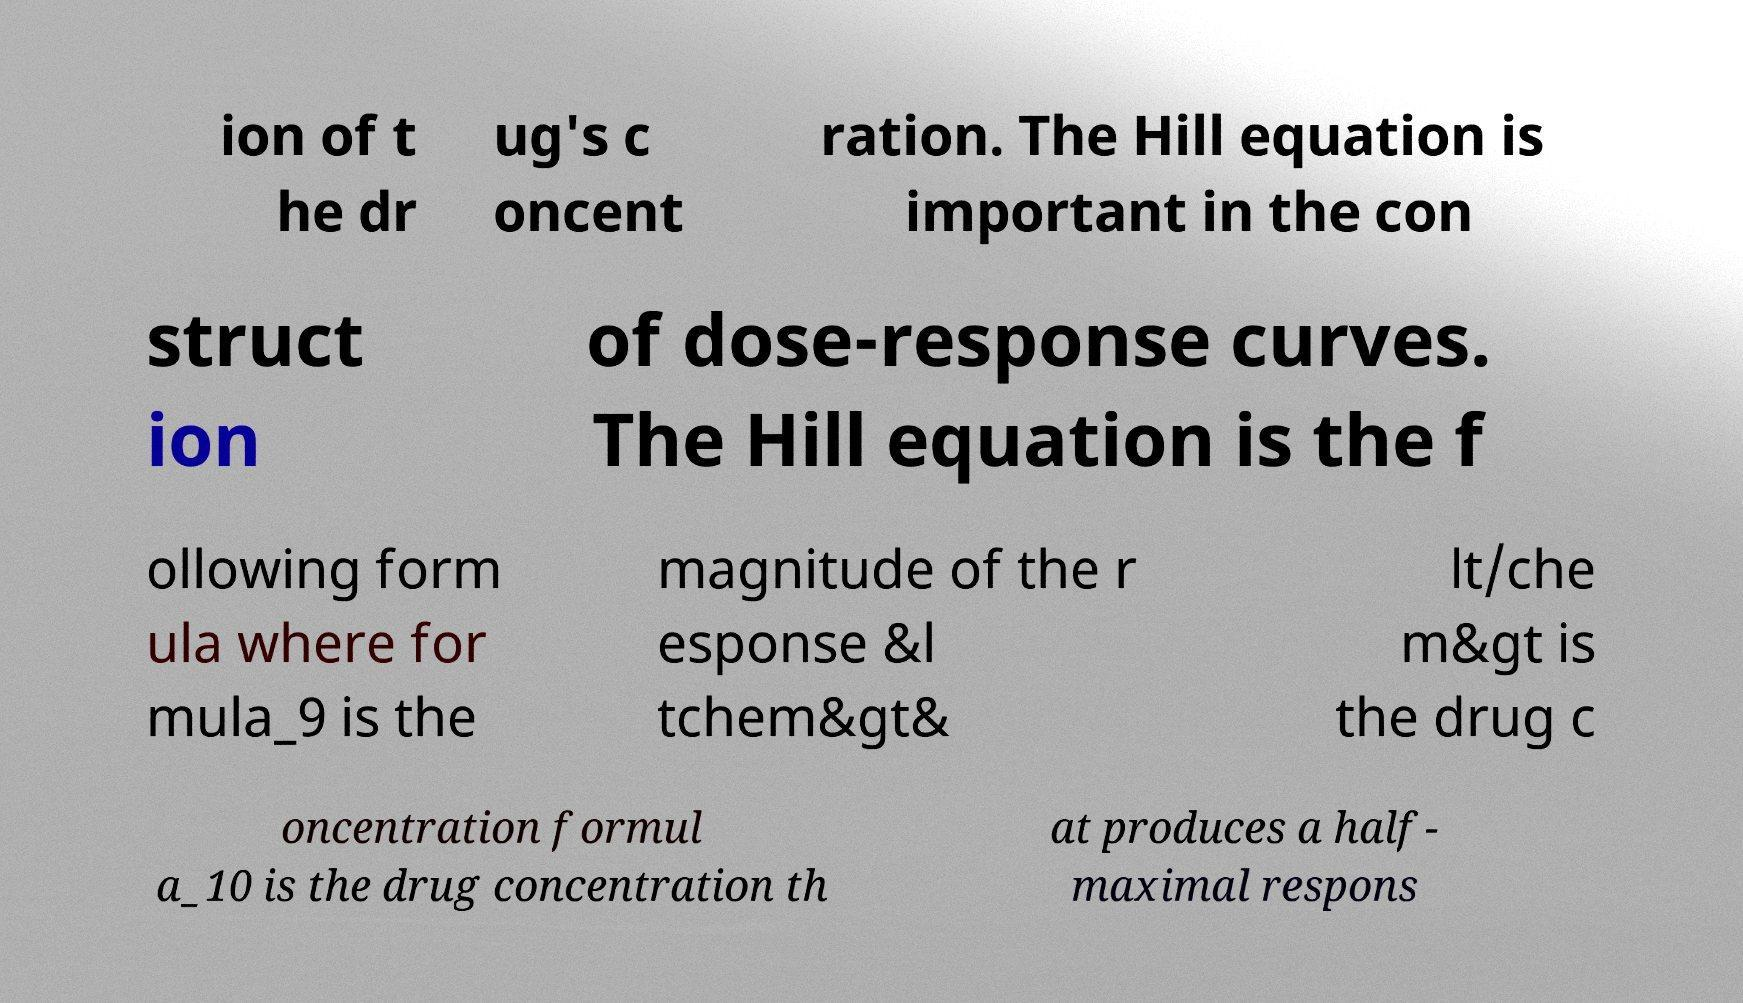Can you read and provide the text displayed in the image?This photo seems to have some interesting text. Can you extract and type it out for me? ion of t he dr ug's c oncent ration. The Hill equation is important in the con struct ion of dose-response curves. The Hill equation is the f ollowing form ula where for mula_9 is the magnitude of the r esponse &l tchem&gt& lt/che m&gt is the drug c oncentration formul a_10 is the drug concentration th at produces a half- maximal respons 